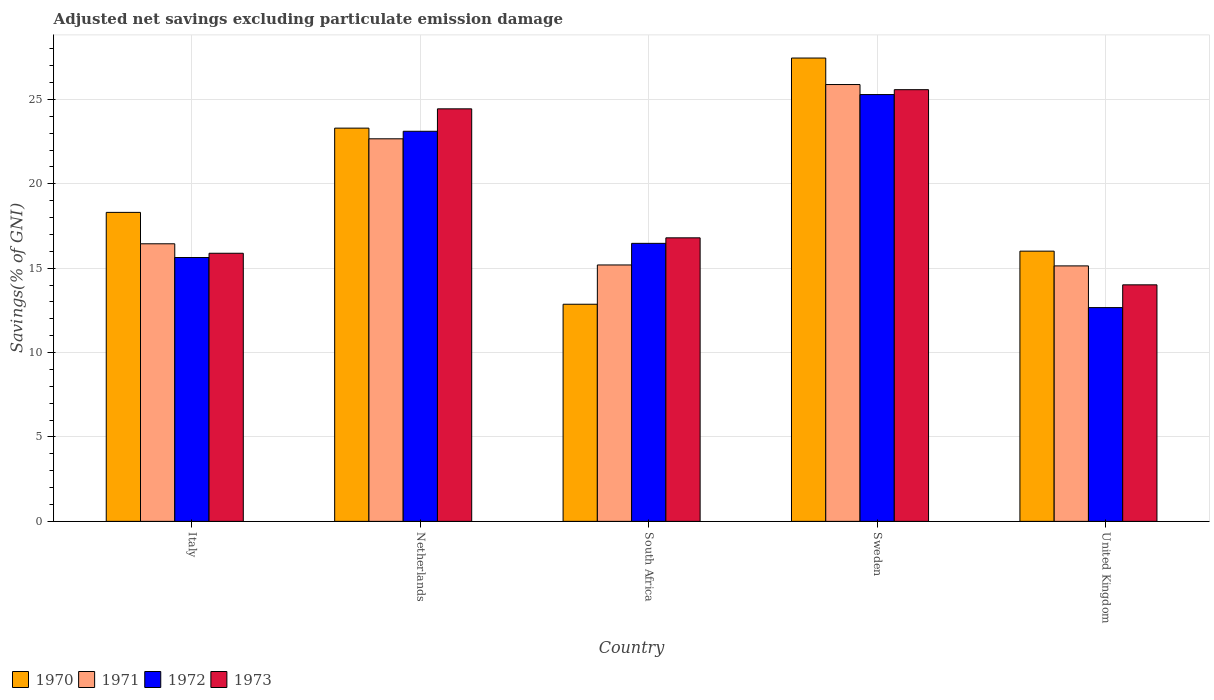Are the number of bars on each tick of the X-axis equal?
Provide a short and direct response. Yes. How many bars are there on the 1st tick from the left?
Provide a succinct answer. 4. What is the adjusted net savings in 1970 in South Africa?
Make the answer very short. 12.86. Across all countries, what is the maximum adjusted net savings in 1971?
Give a very brief answer. 25.88. Across all countries, what is the minimum adjusted net savings in 1970?
Offer a very short reply. 12.86. In which country was the adjusted net savings in 1972 minimum?
Make the answer very short. United Kingdom. What is the total adjusted net savings in 1972 in the graph?
Keep it short and to the point. 93.16. What is the difference between the adjusted net savings in 1970 in Italy and that in Netherlands?
Provide a short and direct response. -4.99. What is the difference between the adjusted net savings in 1971 in Netherlands and the adjusted net savings in 1973 in South Africa?
Your answer should be very brief. 5.87. What is the average adjusted net savings in 1971 per country?
Offer a terse response. 19.06. What is the difference between the adjusted net savings of/in 1972 and adjusted net savings of/in 1970 in Netherlands?
Offer a very short reply. -0.19. What is the ratio of the adjusted net savings in 1971 in Italy to that in Sweden?
Your answer should be very brief. 0.64. Is the adjusted net savings in 1972 in South Africa less than that in United Kingdom?
Your answer should be compact. No. What is the difference between the highest and the second highest adjusted net savings in 1972?
Offer a terse response. -8.81. What is the difference between the highest and the lowest adjusted net savings in 1970?
Ensure brevity in your answer.  14.59. Is it the case that in every country, the sum of the adjusted net savings in 1972 and adjusted net savings in 1971 is greater than the adjusted net savings in 1973?
Keep it short and to the point. Yes. Are all the bars in the graph horizontal?
Make the answer very short. No. How many countries are there in the graph?
Provide a succinct answer. 5. Does the graph contain any zero values?
Give a very brief answer. No. How many legend labels are there?
Your response must be concise. 4. What is the title of the graph?
Provide a short and direct response. Adjusted net savings excluding particulate emission damage. Does "2013" appear as one of the legend labels in the graph?
Your answer should be compact. No. What is the label or title of the X-axis?
Ensure brevity in your answer.  Country. What is the label or title of the Y-axis?
Offer a very short reply. Savings(% of GNI). What is the Savings(% of GNI) of 1970 in Italy?
Your answer should be compact. 18.3. What is the Savings(% of GNI) of 1971 in Italy?
Your answer should be very brief. 16.44. What is the Savings(% of GNI) of 1972 in Italy?
Your response must be concise. 15.63. What is the Savings(% of GNI) of 1973 in Italy?
Provide a succinct answer. 15.88. What is the Savings(% of GNI) in 1970 in Netherlands?
Ensure brevity in your answer.  23.3. What is the Savings(% of GNI) in 1971 in Netherlands?
Ensure brevity in your answer.  22.66. What is the Savings(% of GNI) of 1972 in Netherlands?
Offer a terse response. 23.11. What is the Savings(% of GNI) in 1973 in Netherlands?
Your answer should be compact. 24.44. What is the Savings(% of GNI) in 1970 in South Africa?
Make the answer very short. 12.86. What is the Savings(% of GNI) of 1971 in South Africa?
Offer a terse response. 15.19. What is the Savings(% of GNI) in 1972 in South Africa?
Your response must be concise. 16.47. What is the Savings(% of GNI) of 1973 in South Africa?
Offer a terse response. 16.8. What is the Savings(% of GNI) in 1970 in Sweden?
Keep it short and to the point. 27.45. What is the Savings(% of GNI) in 1971 in Sweden?
Give a very brief answer. 25.88. What is the Savings(% of GNI) in 1972 in Sweden?
Your response must be concise. 25.28. What is the Savings(% of GNI) of 1973 in Sweden?
Your response must be concise. 25.57. What is the Savings(% of GNI) of 1970 in United Kingdom?
Provide a succinct answer. 16.01. What is the Savings(% of GNI) of 1971 in United Kingdom?
Make the answer very short. 15.13. What is the Savings(% of GNI) of 1972 in United Kingdom?
Offer a terse response. 12.66. What is the Savings(% of GNI) of 1973 in United Kingdom?
Ensure brevity in your answer.  14.01. Across all countries, what is the maximum Savings(% of GNI) in 1970?
Offer a very short reply. 27.45. Across all countries, what is the maximum Savings(% of GNI) of 1971?
Your answer should be very brief. 25.88. Across all countries, what is the maximum Savings(% of GNI) of 1972?
Provide a succinct answer. 25.28. Across all countries, what is the maximum Savings(% of GNI) in 1973?
Your response must be concise. 25.57. Across all countries, what is the minimum Savings(% of GNI) in 1970?
Your answer should be compact. 12.86. Across all countries, what is the minimum Savings(% of GNI) of 1971?
Offer a very short reply. 15.13. Across all countries, what is the minimum Savings(% of GNI) in 1972?
Give a very brief answer. 12.66. Across all countries, what is the minimum Savings(% of GNI) in 1973?
Your answer should be very brief. 14.01. What is the total Savings(% of GNI) of 1970 in the graph?
Give a very brief answer. 97.92. What is the total Savings(% of GNI) of 1971 in the graph?
Ensure brevity in your answer.  95.31. What is the total Savings(% of GNI) of 1972 in the graph?
Provide a succinct answer. 93.16. What is the total Savings(% of GNI) of 1973 in the graph?
Offer a terse response. 96.7. What is the difference between the Savings(% of GNI) of 1970 in Italy and that in Netherlands?
Provide a succinct answer. -4.99. What is the difference between the Savings(% of GNI) in 1971 in Italy and that in Netherlands?
Your answer should be compact. -6.22. What is the difference between the Savings(% of GNI) in 1972 in Italy and that in Netherlands?
Your answer should be very brief. -7.48. What is the difference between the Savings(% of GNI) in 1973 in Italy and that in Netherlands?
Your response must be concise. -8.56. What is the difference between the Savings(% of GNI) in 1970 in Italy and that in South Africa?
Your answer should be very brief. 5.44. What is the difference between the Savings(% of GNI) of 1971 in Italy and that in South Africa?
Provide a succinct answer. 1.25. What is the difference between the Savings(% of GNI) in 1972 in Italy and that in South Africa?
Provide a short and direct response. -0.84. What is the difference between the Savings(% of GNI) in 1973 in Italy and that in South Africa?
Make the answer very short. -0.91. What is the difference between the Savings(% of GNI) of 1970 in Italy and that in Sweden?
Offer a terse response. -9.14. What is the difference between the Savings(% of GNI) in 1971 in Italy and that in Sweden?
Provide a succinct answer. -9.43. What is the difference between the Savings(% of GNI) of 1972 in Italy and that in Sweden?
Give a very brief answer. -9.65. What is the difference between the Savings(% of GNI) of 1973 in Italy and that in Sweden?
Give a very brief answer. -9.69. What is the difference between the Savings(% of GNI) of 1970 in Italy and that in United Kingdom?
Give a very brief answer. 2.3. What is the difference between the Savings(% of GNI) in 1971 in Italy and that in United Kingdom?
Make the answer very short. 1.31. What is the difference between the Savings(% of GNI) in 1972 in Italy and that in United Kingdom?
Your answer should be compact. 2.97. What is the difference between the Savings(% of GNI) of 1973 in Italy and that in United Kingdom?
Provide a succinct answer. 1.87. What is the difference between the Savings(% of GNI) in 1970 in Netherlands and that in South Africa?
Provide a short and direct response. 10.43. What is the difference between the Savings(% of GNI) of 1971 in Netherlands and that in South Africa?
Your answer should be very brief. 7.47. What is the difference between the Savings(% of GNI) of 1972 in Netherlands and that in South Africa?
Keep it short and to the point. 6.64. What is the difference between the Savings(% of GNI) in 1973 in Netherlands and that in South Africa?
Offer a terse response. 7.64. What is the difference between the Savings(% of GNI) in 1970 in Netherlands and that in Sweden?
Your answer should be compact. -4.15. What is the difference between the Savings(% of GNI) in 1971 in Netherlands and that in Sweden?
Offer a terse response. -3.21. What is the difference between the Savings(% of GNI) in 1972 in Netherlands and that in Sweden?
Ensure brevity in your answer.  -2.17. What is the difference between the Savings(% of GNI) in 1973 in Netherlands and that in Sweden?
Keep it short and to the point. -1.14. What is the difference between the Savings(% of GNI) in 1970 in Netherlands and that in United Kingdom?
Keep it short and to the point. 7.29. What is the difference between the Savings(% of GNI) in 1971 in Netherlands and that in United Kingdom?
Provide a short and direct response. 7.53. What is the difference between the Savings(% of GNI) of 1972 in Netherlands and that in United Kingdom?
Offer a terse response. 10.45. What is the difference between the Savings(% of GNI) of 1973 in Netherlands and that in United Kingdom?
Offer a very short reply. 10.43. What is the difference between the Savings(% of GNI) of 1970 in South Africa and that in Sweden?
Your response must be concise. -14.59. What is the difference between the Savings(% of GNI) in 1971 in South Africa and that in Sweden?
Keep it short and to the point. -10.69. What is the difference between the Savings(% of GNI) in 1972 in South Africa and that in Sweden?
Make the answer very short. -8.81. What is the difference between the Savings(% of GNI) in 1973 in South Africa and that in Sweden?
Your answer should be very brief. -8.78. What is the difference between the Savings(% of GNI) of 1970 in South Africa and that in United Kingdom?
Your answer should be compact. -3.15. What is the difference between the Savings(% of GNI) in 1971 in South Africa and that in United Kingdom?
Your answer should be compact. 0.06. What is the difference between the Savings(% of GNI) in 1972 in South Africa and that in United Kingdom?
Offer a very short reply. 3.81. What is the difference between the Savings(% of GNI) in 1973 in South Africa and that in United Kingdom?
Your answer should be compact. 2.78. What is the difference between the Savings(% of GNI) in 1970 in Sweden and that in United Kingdom?
Make the answer very short. 11.44. What is the difference between the Savings(% of GNI) of 1971 in Sweden and that in United Kingdom?
Keep it short and to the point. 10.74. What is the difference between the Savings(% of GNI) in 1972 in Sweden and that in United Kingdom?
Provide a short and direct response. 12.62. What is the difference between the Savings(% of GNI) of 1973 in Sweden and that in United Kingdom?
Offer a very short reply. 11.56. What is the difference between the Savings(% of GNI) of 1970 in Italy and the Savings(% of GNI) of 1971 in Netherlands?
Ensure brevity in your answer.  -4.36. What is the difference between the Savings(% of GNI) of 1970 in Italy and the Savings(% of GNI) of 1972 in Netherlands?
Your answer should be compact. -4.81. What is the difference between the Savings(% of GNI) of 1970 in Italy and the Savings(% of GNI) of 1973 in Netherlands?
Make the answer very short. -6.13. What is the difference between the Savings(% of GNI) of 1971 in Italy and the Savings(% of GNI) of 1972 in Netherlands?
Ensure brevity in your answer.  -6.67. What is the difference between the Savings(% of GNI) in 1971 in Italy and the Savings(% of GNI) in 1973 in Netherlands?
Give a very brief answer. -7.99. What is the difference between the Savings(% of GNI) in 1972 in Italy and the Savings(% of GNI) in 1973 in Netherlands?
Your answer should be compact. -8.81. What is the difference between the Savings(% of GNI) of 1970 in Italy and the Savings(% of GNI) of 1971 in South Africa?
Keep it short and to the point. 3.11. What is the difference between the Savings(% of GNI) in 1970 in Italy and the Savings(% of GNI) in 1972 in South Africa?
Offer a terse response. 1.83. What is the difference between the Savings(% of GNI) in 1970 in Italy and the Savings(% of GNI) in 1973 in South Africa?
Offer a very short reply. 1.51. What is the difference between the Savings(% of GNI) in 1971 in Italy and the Savings(% of GNI) in 1972 in South Africa?
Make the answer very short. -0.03. What is the difference between the Savings(% of GNI) of 1971 in Italy and the Savings(% of GNI) of 1973 in South Africa?
Make the answer very short. -0.35. What is the difference between the Savings(% of GNI) in 1972 in Italy and the Savings(% of GNI) in 1973 in South Africa?
Your answer should be very brief. -1.17. What is the difference between the Savings(% of GNI) of 1970 in Italy and the Savings(% of GNI) of 1971 in Sweden?
Provide a succinct answer. -7.57. What is the difference between the Savings(% of GNI) in 1970 in Italy and the Savings(% of GNI) in 1972 in Sweden?
Offer a very short reply. -6.98. What is the difference between the Savings(% of GNI) of 1970 in Italy and the Savings(% of GNI) of 1973 in Sweden?
Give a very brief answer. -7.27. What is the difference between the Savings(% of GNI) in 1971 in Italy and the Savings(% of GNI) in 1972 in Sweden?
Provide a succinct answer. -8.84. What is the difference between the Savings(% of GNI) of 1971 in Italy and the Savings(% of GNI) of 1973 in Sweden?
Your answer should be very brief. -9.13. What is the difference between the Savings(% of GNI) in 1972 in Italy and the Savings(% of GNI) in 1973 in Sweden?
Your response must be concise. -9.94. What is the difference between the Savings(% of GNI) of 1970 in Italy and the Savings(% of GNI) of 1971 in United Kingdom?
Make the answer very short. 3.17. What is the difference between the Savings(% of GNI) of 1970 in Italy and the Savings(% of GNI) of 1972 in United Kingdom?
Provide a succinct answer. 5.64. What is the difference between the Savings(% of GNI) in 1970 in Italy and the Savings(% of GNI) in 1973 in United Kingdom?
Offer a terse response. 4.29. What is the difference between the Savings(% of GNI) in 1971 in Italy and the Savings(% of GNI) in 1972 in United Kingdom?
Your answer should be compact. 3.78. What is the difference between the Savings(% of GNI) of 1971 in Italy and the Savings(% of GNI) of 1973 in United Kingdom?
Offer a very short reply. 2.43. What is the difference between the Savings(% of GNI) of 1972 in Italy and the Savings(% of GNI) of 1973 in United Kingdom?
Your answer should be compact. 1.62. What is the difference between the Savings(% of GNI) in 1970 in Netherlands and the Savings(% of GNI) in 1971 in South Africa?
Offer a terse response. 8.11. What is the difference between the Savings(% of GNI) of 1970 in Netherlands and the Savings(% of GNI) of 1972 in South Africa?
Offer a terse response. 6.83. What is the difference between the Savings(% of GNI) of 1970 in Netherlands and the Savings(% of GNI) of 1973 in South Africa?
Provide a succinct answer. 6.5. What is the difference between the Savings(% of GNI) of 1971 in Netherlands and the Savings(% of GNI) of 1972 in South Africa?
Keep it short and to the point. 6.19. What is the difference between the Savings(% of GNI) of 1971 in Netherlands and the Savings(% of GNI) of 1973 in South Africa?
Offer a very short reply. 5.87. What is the difference between the Savings(% of GNI) of 1972 in Netherlands and the Savings(% of GNI) of 1973 in South Africa?
Offer a very short reply. 6.31. What is the difference between the Savings(% of GNI) in 1970 in Netherlands and the Savings(% of GNI) in 1971 in Sweden?
Provide a succinct answer. -2.58. What is the difference between the Savings(% of GNI) of 1970 in Netherlands and the Savings(% of GNI) of 1972 in Sweden?
Your answer should be very brief. -1.99. What is the difference between the Savings(% of GNI) in 1970 in Netherlands and the Savings(% of GNI) in 1973 in Sweden?
Give a very brief answer. -2.28. What is the difference between the Savings(% of GNI) of 1971 in Netherlands and the Savings(% of GNI) of 1972 in Sweden?
Provide a succinct answer. -2.62. What is the difference between the Savings(% of GNI) in 1971 in Netherlands and the Savings(% of GNI) in 1973 in Sweden?
Provide a succinct answer. -2.91. What is the difference between the Savings(% of GNI) of 1972 in Netherlands and the Savings(% of GNI) of 1973 in Sweden?
Provide a short and direct response. -2.46. What is the difference between the Savings(% of GNI) of 1970 in Netherlands and the Savings(% of GNI) of 1971 in United Kingdom?
Your response must be concise. 8.16. What is the difference between the Savings(% of GNI) in 1970 in Netherlands and the Savings(% of GNI) in 1972 in United Kingdom?
Keep it short and to the point. 10.63. What is the difference between the Savings(% of GNI) in 1970 in Netherlands and the Savings(% of GNI) in 1973 in United Kingdom?
Provide a short and direct response. 9.28. What is the difference between the Savings(% of GNI) in 1971 in Netherlands and the Savings(% of GNI) in 1972 in United Kingdom?
Offer a terse response. 10. What is the difference between the Savings(% of GNI) of 1971 in Netherlands and the Savings(% of GNI) of 1973 in United Kingdom?
Your answer should be compact. 8.65. What is the difference between the Savings(% of GNI) of 1972 in Netherlands and the Savings(% of GNI) of 1973 in United Kingdom?
Ensure brevity in your answer.  9.1. What is the difference between the Savings(% of GNI) in 1970 in South Africa and the Savings(% of GNI) in 1971 in Sweden?
Keep it short and to the point. -13.02. What is the difference between the Savings(% of GNI) in 1970 in South Africa and the Savings(% of GNI) in 1972 in Sweden?
Your answer should be very brief. -12.42. What is the difference between the Savings(% of GNI) in 1970 in South Africa and the Savings(% of GNI) in 1973 in Sweden?
Provide a short and direct response. -12.71. What is the difference between the Savings(% of GNI) in 1971 in South Africa and the Savings(% of GNI) in 1972 in Sweden?
Offer a very short reply. -10.09. What is the difference between the Savings(% of GNI) of 1971 in South Africa and the Savings(% of GNI) of 1973 in Sweden?
Ensure brevity in your answer.  -10.38. What is the difference between the Savings(% of GNI) in 1972 in South Africa and the Savings(% of GNI) in 1973 in Sweden?
Ensure brevity in your answer.  -9.1. What is the difference between the Savings(% of GNI) in 1970 in South Africa and the Savings(% of GNI) in 1971 in United Kingdom?
Make the answer very short. -2.27. What is the difference between the Savings(% of GNI) in 1970 in South Africa and the Savings(% of GNI) in 1972 in United Kingdom?
Keep it short and to the point. 0.2. What is the difference between the Savings(% of GNI) of 1970 in South Africa and the Savings(% of GNI) of 1973 in United Kingdom?
Your answer should be compact. -1.15. What is the difference between the Savings(% of GNI) of 1971 in South Africa and the Savings(% of GNI) of 1972 in United Kingdom?
Your answer should be compact. 2.53. What is the difference between the Savings(% of GNI) of 1971 in South Africa and the Savings(% of GNI) of 1973 in United Kingdom?
Offer a very short reply. 1.18. What is the difference between the Savings(% of GNI) in 1972 in South Africa and the Savings(% of GNI) in 1973 in United Kingdom?
Offer a very short reply. 2.46. What is the difference between the Savings(% of GNI) of 1970 in Sweden and the Savings(% of GNI) of 1971 in United Kingdom?
Offer a very short reply. 12.31. What is the difference between the Savings(% of GNI) of 1970 in Sweden and the Savings(% of GNI) of 1972 in United Kingdom?
Provide a succinct answer. 14.78. What is the difference between the Savings(% of GNI) in 1970 in Sweden and the Savings(% of GNI) in 1973 in United Kingdom?
Give a very brief answer. 13.44. What is the difference between the Savings(% of GNI) in 1971 in Sweden and the Savings(% of GNI) in 1972 in United Kingdom?
Offer a terse response. 13.21. What is the difference between the Savings(% of GNI) in 1971 in Sweden and the Savings(% of GNI) in 1973 in United Kingdom?
Give a very brief answer. 11.87. What is the difference between the Savings(% of GNI) in 1972 in Sweden and the Savings(% of GNI) in 1973 in United Kingdom?
Make the answer very short. 11.27. What is the average Savings(% of GNI) of 1970 per country?
Provide a succinct answer. 19.58. What is the average Savings(% of GNI) of 1971 per country?
Offer a very short reply. 19.06. What is the average Savings(% of GNI) in 1972 per country?
Provide a short and direct response. 18.63. What is the average Savings(% of GNI) in 1973 per country?
Make the answer very short. 19.34. What is the difference between the Savings(% of GNI) of 1970 and Savings(% of GNI) of 1971 in Italy?
Provide a short and direct response. 1.86. What is the difference between the Savings(% of GNI) in 1970 and Savings(% of GNI) in 1972 in Italy?
Offer a very short reply. 2.67. What is the difference between the Savings(% of GNI) in 1970 and Savings(% of GNI) in 1973 in Italy?
Provide a succinct answer. 2.42. What is the difference between the Savings(% of GNI) of 1971 and Savings(% of GNI) of 1972 in Italy?
Provide a short and direct response. 0.81. What is the difference between the Savings(% of GNI) of 1971 and Savings(% of GNI) of 1973 in Italy?
Ensure brevity in your answer.  0.56. What is the difference between the Savings(% of GNI) in 1972 and Savings(% of GNI) in 1973 in Italy?
Provide a short and direct response. -0.25. What is the difference between the Savings(% of GNI) in 1970 and Savings(% of GNI) in 1971 in Netherlands?
Keep it short and to the point. 0.63. What is the difference between the Savings(% of GNI) in 1970 and Savings(% of GNI) in 1972 in Netherlands?
Your answer should be very brief. 0.19. What is the difference between the Savings(% of GNI) of 1970 and Savings(% of GNI) of 1973 in Netherlands?
Make the answer very short. -1.14. What is the difference between the Savings(% of GNI) in 1971 and Savings(% of GNI) in 1972 in Netherlands?
Provide a succinct answer. -0.45. What is the difference between the Savings(% of GNI) of 1971 and Savings(% of GNI) of 1973 in Netherlands?
Make the answer very short. -1.77. What is the difference between the Savings(% of GNI) of 1972 and Savings(% of GNI) of 1973 in Netherlands?
Keep it short and to the point. -1.33. What is the difference between the Savings(% of GNI) in 1970 and Savings(% of GNI) in 1971 in South Africa?
Offer a very short reply. -2.33. What is the difference between the Savings(% of GNI) in 1970 and Savings(% of GNI) in 1972 in South Africa?
Give a very brief answer. -3.61. What is the difference between the Savings(% of GNI) of 1970 and Savings(% of GNI) of 1973 in South Africa?
Offer a terse response. -3.93. What is the difference between the Savings(% of GNI) in 1971 and Savings(% of GNI) in 1972 in South Africa?
Keep it short and to the point. -1.28. What is the difference between the Savings(% of GNI) of 1971 and Savings(% of GNI) of 1973 in South Africa?
Give a very brief answer. -1.61. What is the difference between the Savings(% of GNI) of 1972 and Savings(% of GNI) of 1973 in South Africa?
Ensure brevity in your answer.  -0.33. What is the difference between the Savings(% of GNI) in 1970 and Savings(% of GNI) in 1971 in Sweden?
Offer a very short reply. 1.57. What is the difference between the Savings(% of GNI) in 1970 and Savings(% of GNI) in 1972 in Sweden?
Offer a terse response. 2.16. What is the difference between the Savings(% of GNI) of 1970 and Savings(% of GNI) of 1973 in Sweden?
Ensure brevity in your answer.  1.87. What is the difference between the Savings(% of GNI) in 1971 and Savings(% of GNI) in 1972 in Sweden?
Offer a terse response. 0.59. What is the difference between the Savings(% of GNI) in 1971 and Savings(% of GNI) in 1973 in Sweden?
Your answer should be very brief. 0.3. What is the difference between the Savings(% of GNI) of 1972 and Savings(% of GNI) of 1973 in Sweden?
Provide a short and direct response. -0.29. What is the difference between the Savings(% of GNI) in 1970 and Savings(% of GNI) in 1971 in United Kingdom?
Offer a very short reply. 0.87. What is the difference between the Savings(% of GNI) in 1970 and Savings(% of GNI) in 1972 in United Kingdom?
Ensure brevity in your answer.  3.34. What is the difference between the Savings(% of GNI) in 1970 and Savings(% of GNI) in 1973 in United Kingdom?
Your answer should be compact. 2. What is the difference between the Savings(% of GNI) in 1971 and Savings(% of GNI) in 1972 in United Kingdom?
Provide a succinct answer. 2.47. What is the difference between the Savings(% of GNI) in 1971 and Savings(% of GNI) in 1973 in United Kingdom?
Your response must be concise. 1.12. What is the difference between the Savings(% of GNI) in 1972 and Savings(% of GNI) in 1973 in United Kingdom?
Provide a succinct answer. -1.35. What is the ratio of the Savings(% of GNI) in 1970 in Italy to that in Netherlands?
Your response must be concise. 0.79. What is the ratio of the Savings(% of GNI) in 1971 in Italy to that in Netherlands?
Give a very brief answer. 0.73. What is the ratio of the Savings(% of GNI) of 1972 in Italy to that in Netherlands?
Offer a terse response. 0.68. What is the ratio of the Savings(% of GNI) of 1973 in Italy to that in Netherlands?
Your response must be concise. 0.65. What is the ratio of the Savings(% of GNI) in 1970 in Italy to that in South Africa?
Make the answer very short. 1.42. What is the ratio of the Savings(% of GNI) in 1971 in Italy to that in South Africa?
Make the answer very short. 1.08. What is the ratio of the Savings(% of GNI) of 1972 in Italy to that in South Africa?
Make the answer very short. 0.95. What is the ratio of the Savings(% of GNI) of 1973 in Italy to that in South Africa?
Your answer should be very brief. 0.95. What is the ratio of the Savings(% of GNI) of 1970 in Italy to that in Sweden?
Offer a terse response. 0.67. What is the ratio of the Savings(% of GNI) in 1971 in Italy to that in Sweden?
Offer a terse response. 0.64. What is the ratio of the Savings(% of GNI) in 1972 in Italy to that in Sweden?
Your response must be concise. 0.62. What is the ratio of the Savings(% of GNI) in 1973 in Italy to that in Sweden?
Your answer should be compact. 0.62. What is the ratio of the Savings(% of GNI) of 1970 in Italy to that in United Kingdom?
Provide a short and direct response. 1.14. What is the ratio of the Savings(% of GNI) in 1971 in Italy to that in United Kingdom?
Keep it short and to the point. 1.09. What is the ratio of the Savings(% of GNI) in 1972 in Italy to that in United Kingdom?
Offer a terse response. 1.23. What is the ratio of the Savings(% of GNI) in 1973 in Italy to that in United Kingdom?
Offer a very short reply. 1.13. What is the ratio of the Savings(% of GNI) of 1970 in Netherlands to that in South Africa?
Your answer should be compact. 1.81. What is the ratio of the Savings(% of GNI) of 1971 in Netherlands to that in South Africa?
Keep it short and to the point. 1.49. What is the ratio of the Savings(% of GNI) in 1972 in Netherlands to that in South Africa?
Your answer should be compact. 1.4. What is the ratio of the Savings(% of GNI) of 1973 in Netherlands to that in South Africa?
Give a very brief answer. 1.46. What is the ratio of the Savings(% of GNI) in 1970 in Netherlands to that in Sweden?
Give a very brief answer. 0.85. What is the ratio of the Savings(% of GNI) of 1971 in Netherlands to that in Sweden?
Give a very brief answer. 0.88. What is the ratio of the Savings(% of GNI) in 1972 in Netherlands to that in Sweden?
Ensure brevity in your answer.  0.91. What is the ratio of the Savings(% of GNI) of 1973 in Netherlands to that in Sweden?
Your answer should be very brief. 0.96. What is the ratio of the Savings(% of GNI) in 1970 in Netherlands to that in United Kingdom?
Offer a very short reply. 1.46. What is the ratio of the Savings(% of GNI) in 1971 in Netherlands to that in United Kingdom?
Ensure brevity in your answer.  1.5. What is the ratio of the Savings(% of GNI) in 1972 in Netherlands to that in United Kingdom?
Make the answer very short. 1.82. What is the ratio of the Savings(% of GNI) of 1973 in Netherlands to that in United Kingdom?
Keep it short and to the point. 1.74. What is the ratio of the Savings(% of GNI) in 1970 in South Africa to that in Sweden?
Keep it short and to the point. 0.47. What is the ratio of the Savings(% of GNI) of 1971 in South Africa to that in Sweden?
Offer a very short reply. 0.59. What is the ratio of the Savings(% of GNI) in 1972 in South Africa to that in Sweden?
Your answer should be very brief. 0.65. What is the ratio of the Savings(% of GNI) of 1973 in South Africa to that in Sweden?
Provide a short and direct response. 0.66. What is the ratio of the Savings(% of GNI) in 1970 in South Africa to that in United Kingdom?
Offer a terse response. 0.8. What is the ratio of the Savings(% of GNI) in 1972 in South Africa to that in United Kingdom?
Your answer should be compact. 1.3. What is the ratio of the Savings(% of GNI) of 1973 in South Africa to that in United Kingdom?
Your answer should be compact. 1.2. What is the ratio of the Savings(% of GNI) in 1970 in Sweden to that in United Kingdom?
Keep it short and to the point. 1.71. What is the ratio of the Savings(% of GNI) in 1971 in Sweden to that in United Kingdom?
Your response must be concise. 1.71. What is the ratio of the Savings(% of GNI) of 1972 in Sweden to that in United Kingdom?
Offer a very short reply. 2. What is the ratio of the Savings(% of GNI) in 1973 in Sweden to that in United Kingdom?
Give a very brief answer. 1.83. What is the difference between the highest and the second highest Savings(% of GNI) in 1970?
Make the answer very short. 4.15. What is the difference between the highest and the second highest Savings(% of GNI) of 1971?
Provide a succinct answer. 3.21. What is the difference between the highest and the second highest Savings(% of GNI) of 1972?
Offer a terse response. 2.17. What is the difference between the highest and the second highest Savings(% of GNI) in 1973?
Make the answer very short. 1.14. What is the difference between the highest and the lowest Savings(% of GNI) of 1970?
Your answer should be compact. 14.59. What is the difference between the highest and the lowest Savings(% of GNI) of 1971?
Offer a very short reply. 10.74. What is the difference between the highest and the lowest Savings(% of GNI) of 1972?
Give a very brief answer. 12.62. What is the difference between the highest and the lowest Savings(% of GNI) in 1973?
Give a very brief answer. 11.56. 